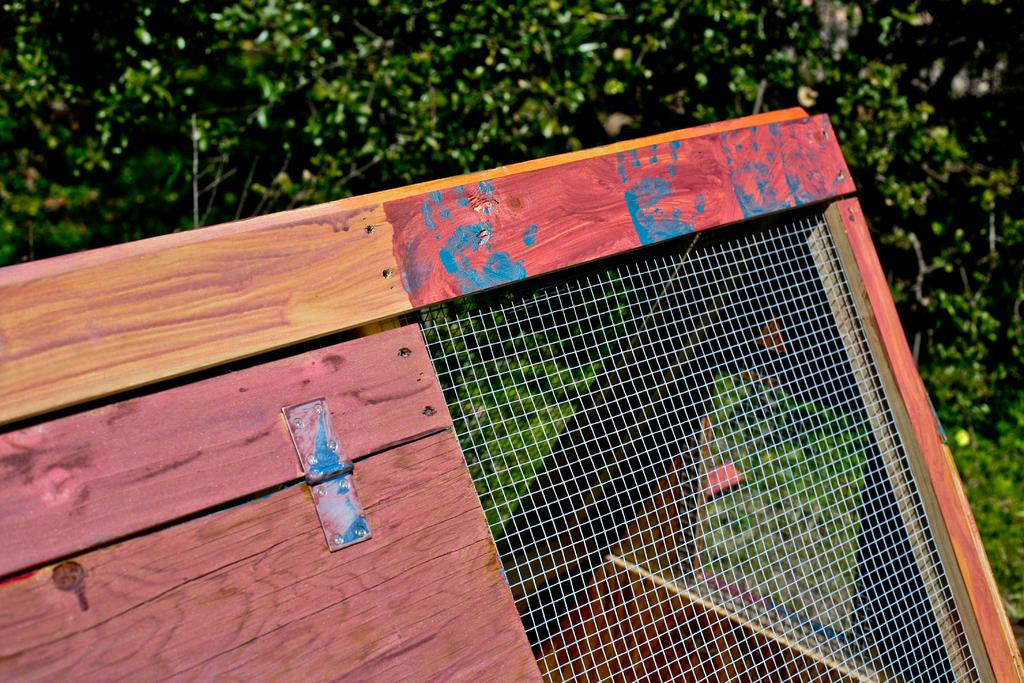What type of door is visible in the image? There is a wooden door in the image. What can be seen besides the door in the image? There is a net fence in the image. What type of natural scenery is visible in the background of the image? There are trees in the background of the image. How many gloves are being used to work on the door in the image? There are no gloves or any indication of work being done on the door in the image. 